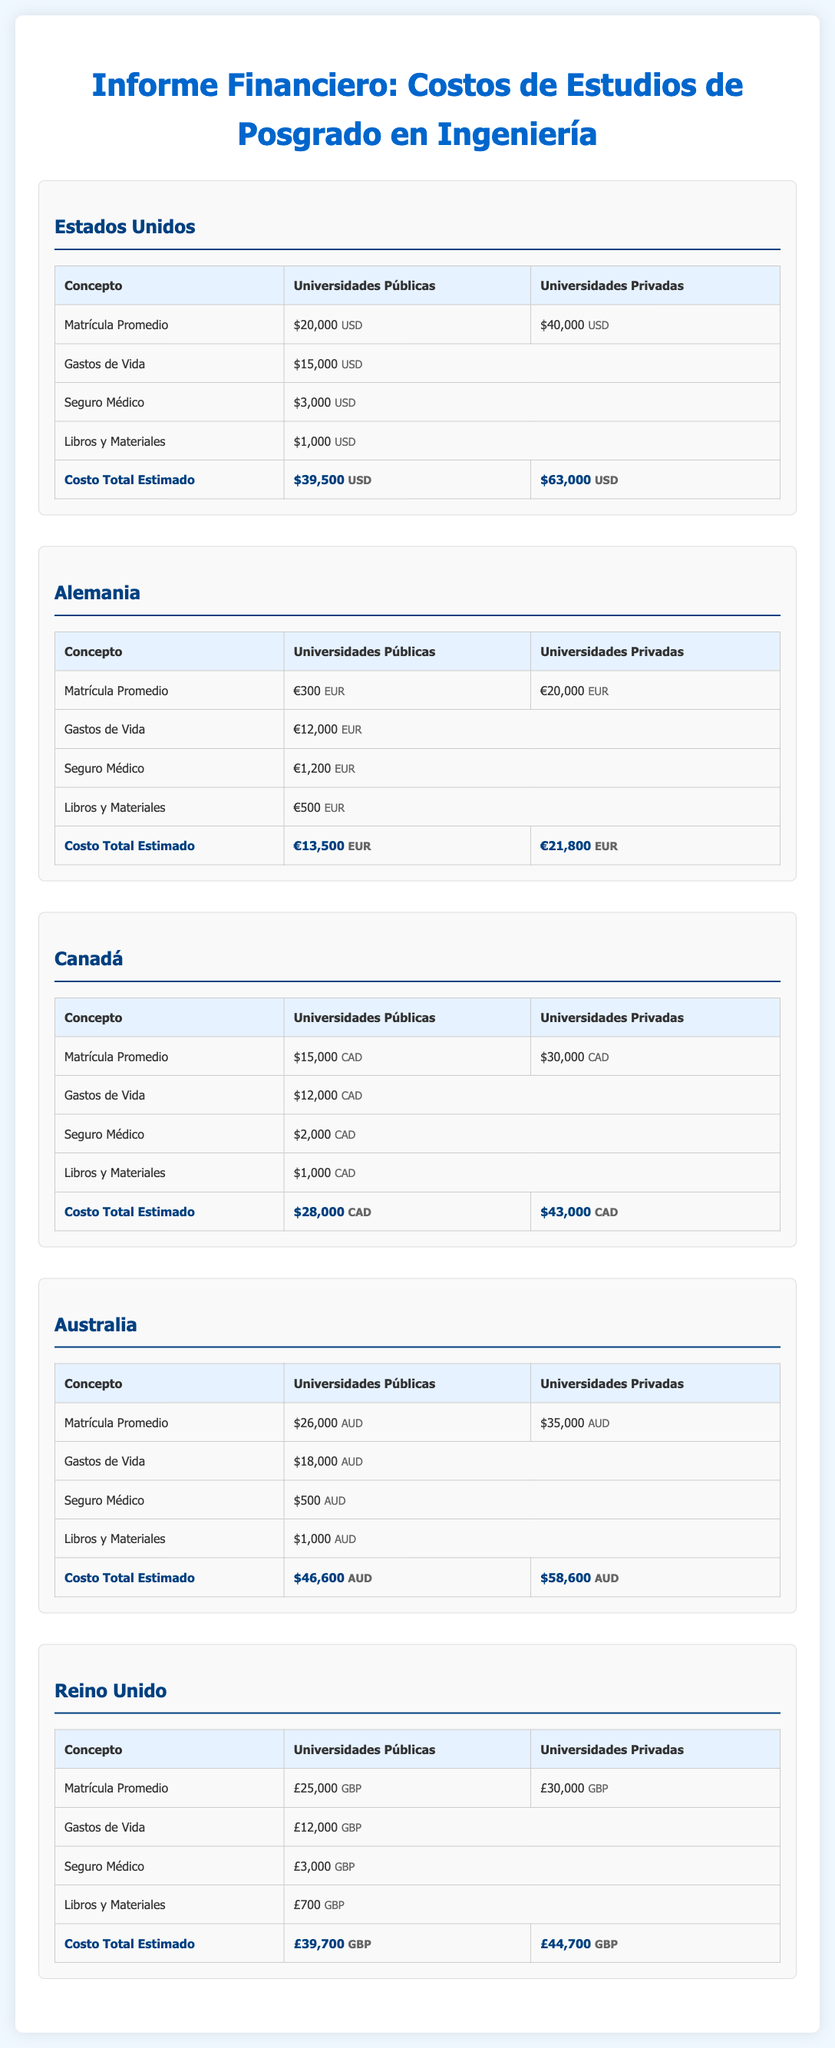¿Cuál es la matrícula promedio en universidades públicas en Estados Unidos? La matrícula promedio en universidades públicas en Estados Unidos es de $20,000 USD.
Answer: $20,000 USD ¿Cuál es el costo total estimado para estudiar en universidades privadas en Alemania? El costo total estimado para estudiar en universidades privadas en Alemania es de €21,800 EUR.
Answer: €21,800 EUR ¿Qué gastos de vida se estiman para los estudiantes en Canadá? Los gastos de vida estimados para los estudiantes en Canadá son $12,000 CAD.
Answer: $12,000 CAD ¿Cuánto se estima que costarán los libros y materiales en Australia? Se estima que los libros y materiales en Australia costarán $1,000 AUD.
Answer: $1,000 AUD ¿Cuál es el costo total estimado para estudiar en universidades públicas en Reino Unido? El costo total estimado para estudiar en universidades públicas en el Reino Unido es de £39,700 GBP.
Answer: £39,700 GBP ¿Cuánto es el seguro médico en universidades privadas en Estados Unidos? El seguro médico en universidades privadas en Estados Unidos es de $3,000 USD.
Answer: $3,000 USD ¿En qué país es la matrícula promedio más baja? La matrícula promedio más baja es en Alemania, con €300 EUR.
Answer: €300 EUR ¿Cuáles son las dos categorías de universidades mencionadas en el informe? Las dos categorías de universidades mencionadas son universidades públicas y universidades privadas.
Answer: universidades públicas y universidades privadas ¿Cuál es la moneda utilizada en el informe para Alemania? La moneda utilizada en el informe para Alemania es el euro.
Answer: euro 